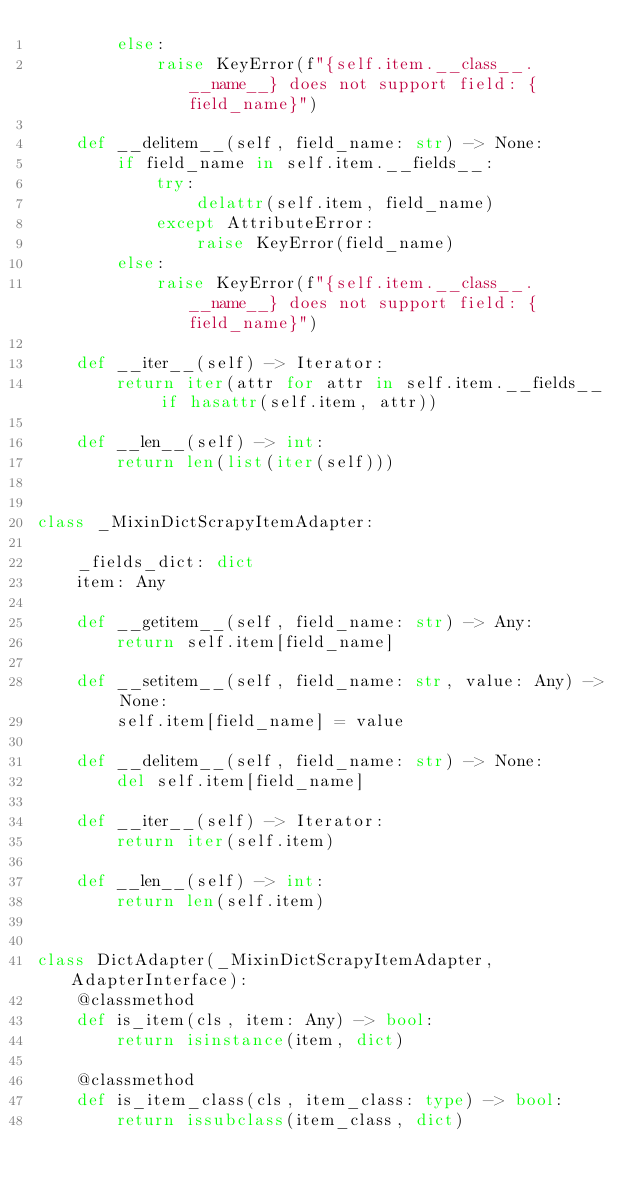Convert code to text. <code><loc_0><loc_0><loc_500><loc_500><_Python_>        else:
            raise KeyError(f"{self.item.__class__.__name__} does not support field: {field_name}")

    def __delitem__(self, field_name: str) -> None:
        if field_name in self.item.__fields__:
            try:
                delattr(self.item, field_name)
            except AttributeError:
                raise KeyError(field_name)
        else:
            raise KeyError(f"{self.item.__class__.__name__} does not support field: {field_name}")

    def __iter__(self) -> Iterator:
        return iter(attr for attr in self.item.__fields__ if hasattr(self.item, attr))

    def __len__(self) -> int:
        return len(list(iter(self)))


class _MixinDictScrapyItemAdapter:

    _fields_dict: dict
    item: Any

    def __getitem__(self, field_name: str) -> Any:
        return self.item[field_name]

    def __setitem__(self, field_name: str, value: Any) -> None:
        self.item[field_name] = value

    def __delitem__(self, field_name: str) -> None:
        del self.item[field_name]

    def __iter__(self) -> Iterator:
        return iter(self.item)

    def __len__(self) -> int:
        return len(self.item)


class DictAdapter(_MixinDictScrapyItemAdapter, AdapterInterface):
    @classmethod
    def is_item(cls, item: Any) -> bool:
        return isinstance(item, dict)

    @classmethod
    def is_item_class(cls, item_class: type) -> bool:
        return issubclass(item_class, dict)
</code> 